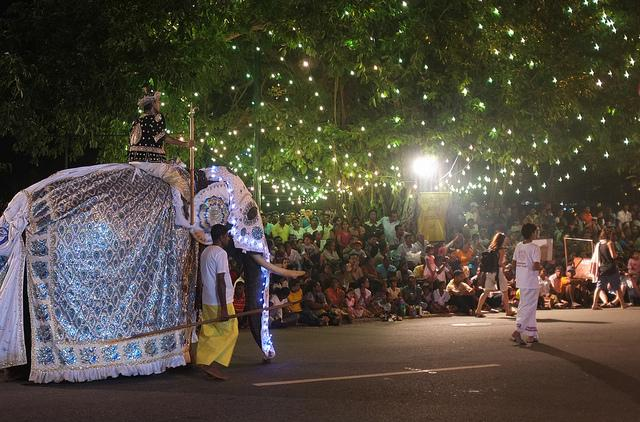Which part of the animal is precious? Please explain your reasoning. ivory. The elephant has tusks made of ivory that are worth a lot of money. 